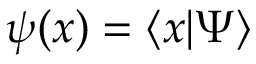Convert formula to latex. <formula><loc_0><loc_0><loc_500><loc_500>\psi ( x ) = \langle x | \Psi \rangle</formula> 